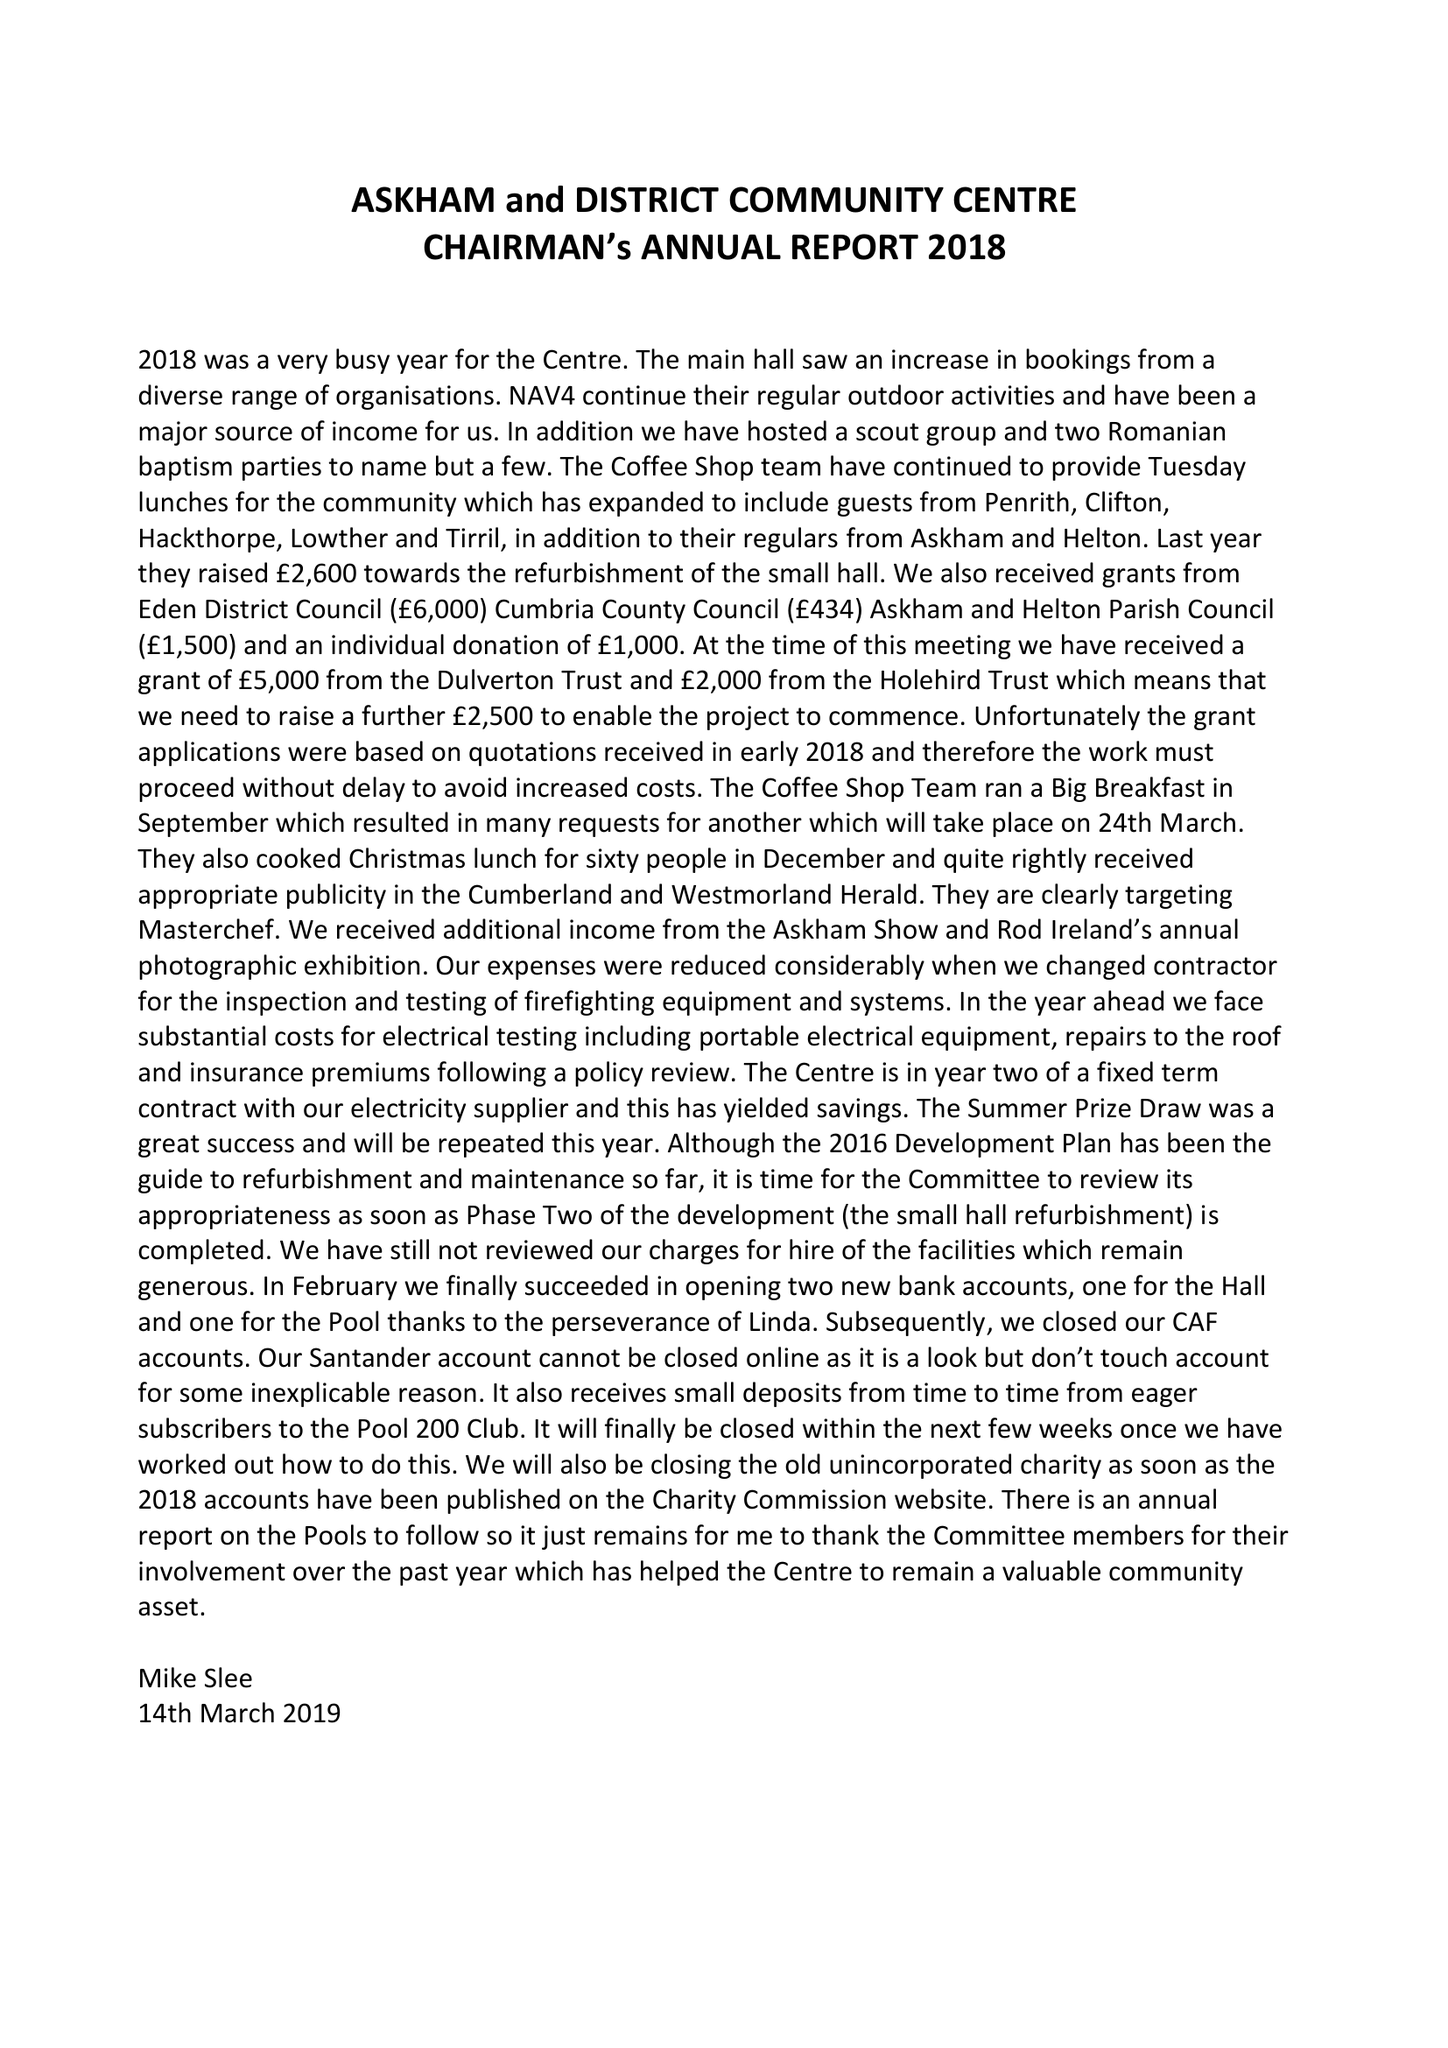What is the value for the spending_annually_in_british_pounds?
Answer the question using a single word or phrase. 45641.00 